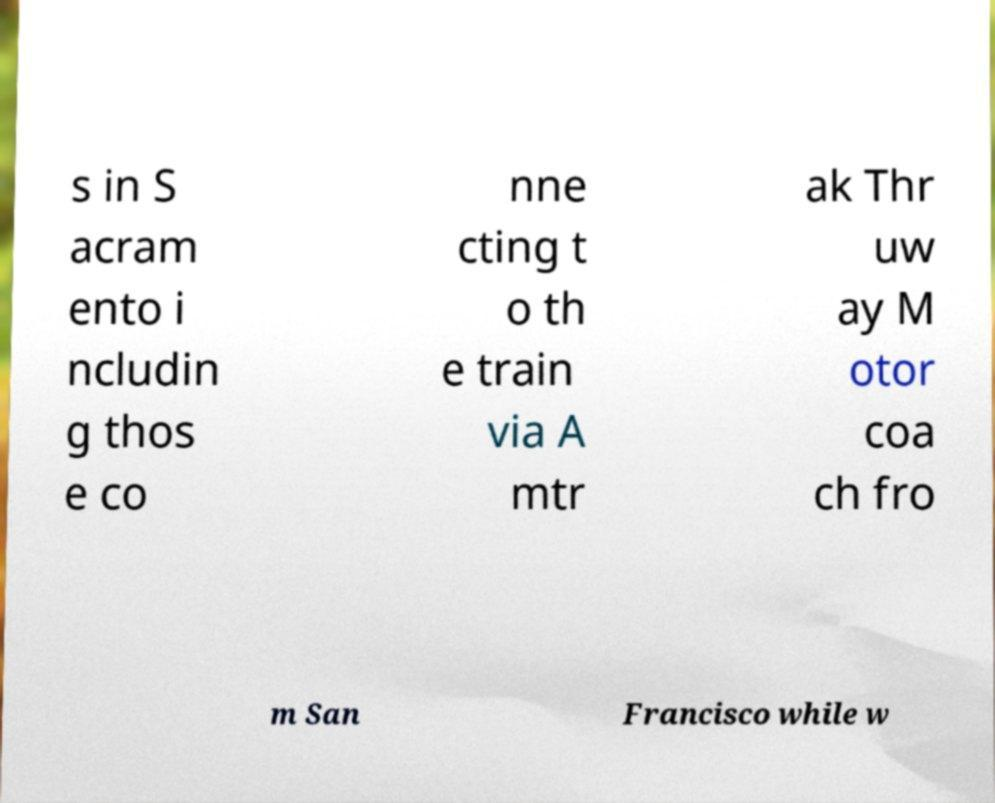For documentation purposes, I need the text within this image transcribed. Could you provide that? s in S acram ento i ncludin g thos e co nne cting t o th e train via A mtr ak Thr uw ay M otor coa ch fro m San Francisco while w 